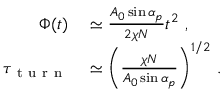<formula> <loc_0><loc_0><loc_500><loc_500>\begin{array} { r l } { \Phi ( t ) } & \simeq \frac { A _ { 0 } \sin \alpha _ { p } } { 2 \chi N } t ^ { 2 } \ , } \\ { \tau _ { t u r n } } & \simeq \left ( \frac { \chi N } { A _ { 0 } \sin \alpha _ { p } } \right ) ^ { 1 / 2 } \, . } \end{array}</formula> 